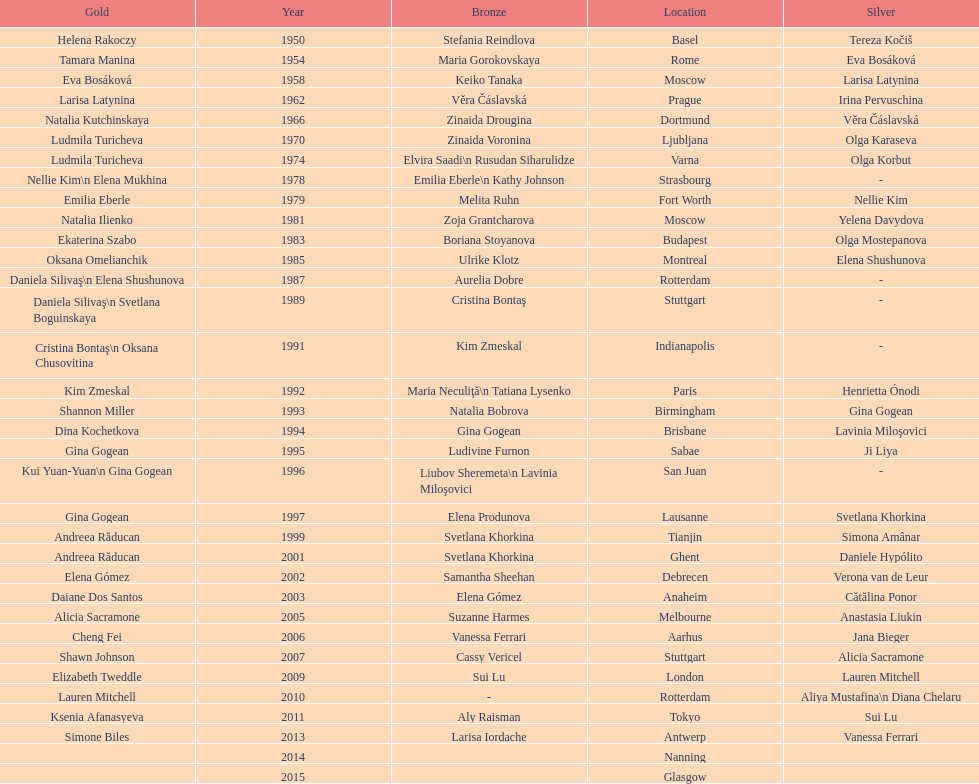How many times was the location in the united states? 3. 